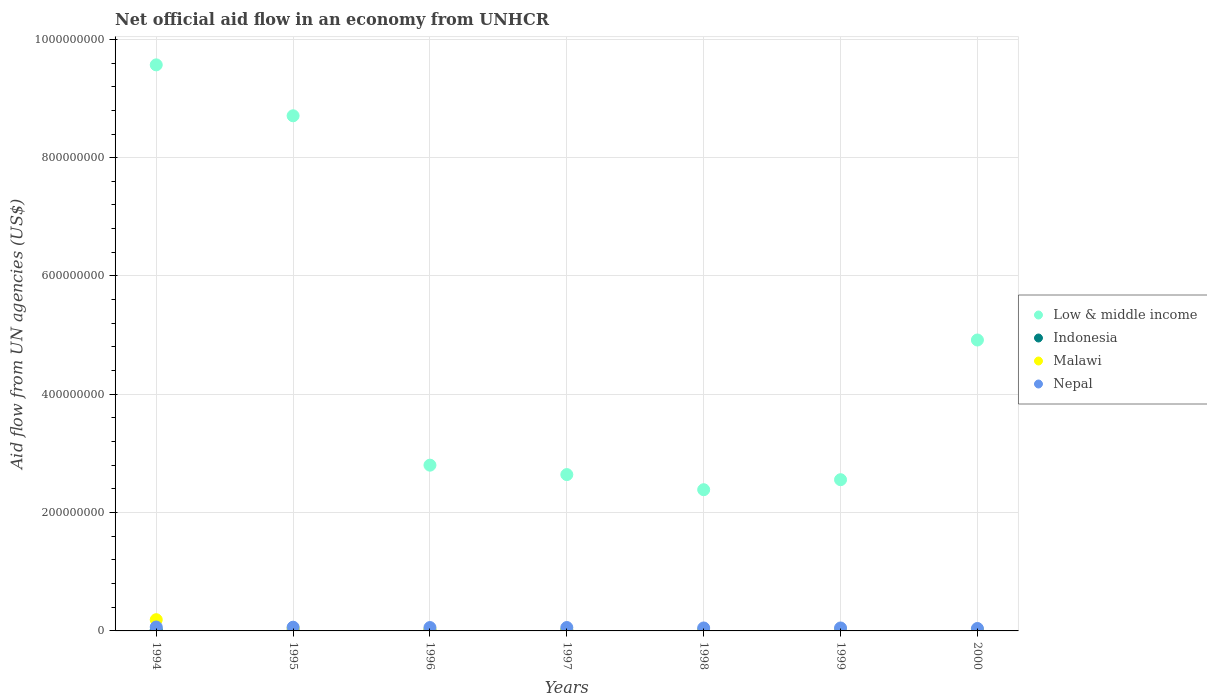Is the number of dotlines equal to the number of legend labels?
Make the answer very short. Yes. What is the net official aid flow in Indonesia in 1994?
Give a very brief answer. 1.96e+06. Across all years, what is the maximum net official aid flow in Malawi?
Offer a terse response. 1.90e+07. Across all years, what is the minimum net official aid flow in Malawi?
Offer a terse response. 7.90e+05. In which year was the net official aid flow in Malawi maximum?
Provide a short and direct response. 1994. What is the total net official aid flow in Nepal in the graph?
Ensure brevity in your answer.  3.84e+07. What is the difference between the net official aid flow in Malawi in 1994 and that in 2000?
Provide a succinct answer. 1.82e+07. What is the difference between the net official aid flow in Malawi in 2000 and the net official aid flow in Low & middle income in 1996?
Provide a short and direct response. -2.79e+08. What is the average net official aid flow in Indonesia per year?
Give a very brief answer. 8.81e+05. In the year 1995, what is the difference between the net official aid flow in Indonesia and net official aid flow in Malawi?
Your answer should be very brief. -3.82e+06. What is the ratio of the net official aid flow in Indonesia in 1999 to that in 2000?
Offer a very short reply. 0.76. Is the difference between the net official aid flow in Indonesia in 1994 and 1998 greater than the difference between the net official aid flow in Malawi in 1994 and 1998?
Provide a succinct answer. No. What is the difference between the highest and the second highest net official aid flow in Nepal?
Ensure brevity in your answer.  3.30e+05. What is the difference between the highest and the lowest net official aid flow in Indonesia?
Offer a very short reply. 1.54e+06. Is it the case that in every year, the sum of the net official aid flow in Indonesia and net official aid flow in Malawi  is greater than the sum of net official aid flow in Nepal and net official aid flow in Low & middle income?
Make the answer very short. No. Is it the case that in every year, the sum of the net official aid flow in Low & middle income and net official aid flow in Nepal  is greater than the net official aid flow in Malawi?
Provide a short and direct response. Yes. Is the net official aid flow in Indonesia strictly greater than the net official aid flow in Nepal over the years?
Make the answer very short. No. How many dotlines are there?
Make the answer very short. 4. How many years are there in the graph?
Your answer should be compact. 7. Are the values on the major ticks of Y-axis written in scientific E-notation?
Your answer should be very brief. No. Where does the legend appear in the graph?
Give a very brief answer. Center right. How are the legend labels stacked?
Your answer should be very brief. Vertical. What is the title of the graph?
Your response must be concise. Net official aid flow in an economy from UNHCR. What is the label or title of the X-axis?
Provide a short and direct response. Years. What is the label or title of the Y-axis?
Ensure brevity in your answer.  Aid flow from UN agencies (US$). What is the Aid flow from UN agencies (US$) of Low & middle income in 1994?
Offer a very short reply. 9.57e+08. What is the Aid flow from UN agencies (US$) of Indonesia in 1994?
Make the answer very short. 1.96e+06. What is the Aid flow from UN agencies (US$) of Malawi in 1994?
Offer a terse response. 1.90e+07. What is the Aid flow from UN agencies (US$) in Nepal in 1994?
Your answer should be compact. 6.61e+06. What is the Aid flow from UN agencies (US$) of Low & middle income in 1995?
Offer a very short reply. 8.71e+08. What is the Aid flow from UN agencies (US$) in Malawi in 1995?
Offer a very short reply. 4.24e+06. What is the Aid flow from UN agencies (US$) of Nepal in 1995?
Provide a succinct answer. 6.28e+06. What is the Aid flow from UN agencies (US$) of Low & middle income in 1996?
Ensure brevity in your answer.  2.80e+08. What is the Aid flow from UN agencies (US$) of Indonesia in 1996?
Offer a very short reply. 5.80e+05. What is the Aid flow from UN agencies (US$) in Malawi in 1996?
Ensure brevity in your answer.  2.13e+06. What is the Aid flow from UN agencies (US$) of Nepal in 1996?
Give a very brief answer. 5.70e+06. What is the Aid flow from UN agencies (US$) of Low & middle income in 1997?
Your response must be concise. 2.64e+08. What is the Aid flow from UN agencies (US$) of Indonesia in 1997?
Provide a succinct answer. 7.30e+05. What is the Aid flow from UN agencies (US$) of Malawi in 1997?
Keep it short and to the point. 1.35e+06. What is the Aid flow from UN agencies (US$) of Nepal in 1997?
Your answer should be very brief. 5.74e+06. What is the Aid flow from UN agencies (US$) in Low & middle income in 1998?
Your response must be concise. 2.39e+08. What is the Aid flow from UN agencies (US$) in Malawi in 1998?
Offer a very short reply. 1.03e+06. What is the Aid flow from UN agencies (US$) of Nepal in 1998?
Your response must be concise. 4.99e+06. What is the Aid flow from UN agencies (US$) of Low & middle income in 1999?
Make the answer very short. 2.56e+08. What is the Aid flow from UN agencies (US$) of Indonesia in 1999?
Ensure brevity in your answer.  8.70e+05. What is the Aid flow from UN agencies (US$) of Malawi in 1999?
Provide a succinct answer. 8.20e+05. What is the Aid flow from UN agencies (US$) in Nepal in 1999?
Keep it short and to the point. 4.98e+06. What is the Aid flow from UN agencies (US$) in Low & middle income in 2000?
Make the answer very short. 4.92e+08. What is the Aid flow from UN agencies (US$) of Indonesia in 2000?
Offer a terse response. 1.14e+06. What is the Aid flow from UN agencies (US$) in Malawi in 2000?
Your answer should be very brief. 7.90e+05. What is the Aid flow from UN agencies (US$) of Nepal in 2000?
Make the answer very short. 4.12e+06. Across all years, what is the maximum Aid flow from UN agencies (US$) of Low & middle income?
Offer a terse response. 9.57e+08. Across all years, what is the maximum Aid flow from UN agencies (US$) of Indonesia?
Your answer should be very brief. 1.96e+06. Across all years, what is the maximum Aid flow from UN agencies (US$) in Malawi?
Offer a terse response. 1.90e+07. Across all years, what is the maximum Aid flow from UN agencies (US$) of Nepal?
Provide a succinct answer. 6.61e+06. Across all years, what is the minimum Aid flow from UN agencies (US$) of Low & middle income?
Your response must be concise. 2.39e+08. Across all years, what is the minimum Aid flow from UN agencies (US$) in Indonesia?
Offer a terse response. 4.20e+05. Across all years, what is the minimum Aid flow from UN agencies (US$) of Malawi?
Ensure brevity in your answer.  7.90e+05. Across all years, what is the minimum Aid flow from UN agencies (US$) in Nepal?
Give a very brief answer. 4.12e+06. What is the total Aid flow from UN agencies (US$) in Low & middle income in the graph?
Offer a terse response. 3.36e+09. What is the total Aid flow from UN agencies (US$) in Indonesia in the graph?
Your answer should be compact. 6.17e+06. What is the total Aid flow from UN agencies (US$) of Malawi in the graph?
Offer a very short reply. 2.93e+07. What is the total Aid flow from UN agencies (US$) of Nepal in the graph?
Your answer should be compact. 3.84e+07. What is the difference between the Aid flow from UN agencies (US$) in Low & middle income in 1994 and that in 1995?
Your response must be concise. 8.61e+07. What is the difference between the Aid flow from UN agencies (US$) in Indonesia in 1994 and that in 1995?
Your response must be concise. 1.54e+06. What is the difference between the Aid flow from UN agencies (US$) in Malawi in 1994 and that in 1995?
Keep it short and to the point. 1.47e+07. What is the difference between the Aid flow from UN agencies (US$) in Low & middle income in 1994 and that in 1996?
Keep it short and to the point. 6.77e+08. What is the difference between the Aid flow from UN agencies (US$) in Indonesia in 1994 and that in 1996?
Ensure brevity in your answer.  1.38e+06. What is the difference between the Aid flow from UN agencies (US$) of Malawi in 1994 and that in 1996?
Offer a terse response. 1.68e+07. What is the difference between the Aid flow from UN agencies (US$) of Nepal in 1994 and that in 1996?
Provide a succinct answer. 9.10e+05. What is the difference between the Aid flow from UN agencies (US$) of Low & middle income in 1994 and that in 1997?
Provide a succinct answer. 6.93e+08. What is the difference between the Aid flow from UN agencies (US$) in Indonesia in 1994 and that in 1997?
Make the answer very short. 1.23e+06. What is the difference between the Aid flow from UN agencies (US$) in Malawi in 1994 and that in 1997?
Your answer should be compact. 1.76e+07. What is the difference between the Aid flow from UN agencies (US$) in Nepal in 1994 and that in 1997?
Keep it short and to the point. 8.70e+05. What is the difference between the Aid flow from UN agencies (US$) in Low & middle income in 1994 and that in 1998?
Keep it short and to the point. 7.18e+08. What is the difference between the Aid flow from UN agencies (US$) in Indonesia in 1994 and that in 1998?
Offer a very short reply. 1.49e+06. What is the difference between the Aid flow from UN agencies (US$) of Malawi in 1994 and that in 1998?
Make the answer very short. 1.80e+07. What is the difference between the Aid flow from UN agencies (US$) in Nepal in 1994 and that in 1998?
Make the answer very short. 1.62e+06. What is the difference between the Aid flow from UN agencies (US$) of Low & middle income in 1994 and that in 1999?
Provide a succinct answer. 7.01e+08. What is the difference between the Aid flow from UN agencies (US$) of Indonesia in 1994 and that in 1999?
Ensure brevity in your answer.  1.09e+06. What is the difference between the Aid flow from UN agencies (US$) in Malawi in 1994 and that in 1999?
Keep it short and to the point. 1.82e+07. What is the difference between the Aid flow from UN agencies (US$) in Nepal in 1994 and that in 1999?
Your answer should be compact. 1.63e+06. What is the difference between the Aid flow from UN agencies (US$) in Low & middle income in 1994 and that in 2000?
Give a very brief answer. 4.65e+08. What is the difference between the Aid flow from UN agencies (US$) in Indonesia in 1994 and that in 2000?
Offer a terse response. 8.20e+05. What is the difference between the Aid flow from UN agencies (US$) of Malawi in 1994 and that in 2000?
Your answer should be compact. 1.82e+07. What is the difference between the Aid flow from UN agencies (US$) of Nepal in 1994 and that in 2000?
Offer a very short reply. 2.49e+06. What is the difference between the Aid flow from UN agencies (US$) of Low & middle income in 1995 and that in 1996?
Give a very brief answer. 5.91e+08. What is the difference between the Aid flow from UN agencies (US$) in Malawi in 1995 and that in 1996?
Offer a terse response. 2.11e+06. What is the difference between the Aid flow from UN agencies (US$) in Nepal in 1995 and that in 1996?
Provide a short and direct response. 5.80e+05. What is the difference between the Aid flow from UN agencies (US$) in Low & middle income in 1995 and that in 1997?
Offer a very short reply. 6.07e+08. What is the difference between the Aid flow from UN agencies (US$) in Indonesia in 1995 and that in 1997?
Keep it short and to the point. -3.10e+05. What is the difference between the Aid flow from UN agencies (US$) in Malawi in 1995 and that in 1997?
Provide a short and direct response. 2.89e+06. What is the difference between the Aid flow from UN agencies (US$) of Nepal in 1995 and that in 1997?
Make the answer very short. 5.40e+05. What is the difference between the Aid flow from UN agencies (US$) in Low & middle income in 1995 and that in 1998?
Give a very brief answer. 6.32e+08. What is the difference between the Aid flow from UN agencies (US$) of Malawi in 1995 and that in 1998?
Your answer should be very brief. 3.21e+06. What is the difference between the Aid flow from UN agencies (US$) in Nepal in 1995 and that in 1998?
Offer a terse response. 1.29e+06. What is the difference between the Aid flow from UN agencies (US$) of Low & middle income in 1995 and that in 1999?
Your answer should be compact. 6.15e+08. What is the difference between the Aid flow from UN agencies (US$) in Indonesia in 1995 and that in 1999?
Ensure brevity in your answer.  -4.50e+05. What is the difference between the Aid flow from UN agencies (US$) of Malawi in 1995 and that in 1999?
Your answer should be compact. 3.42e+06. What is the difference between the Aid flow from UN agencies (US$) in Nepal in 1995 and that in 1999?
Offer a very short reply. 1.30e+06. What is the difference between the Aid flow from UN agencies (US$) of Low & middle income in 1995 and that in 2000?
Make the answer very short. 3.79e+08. What is the difference between the Aid flow from UN agencies (US$) in Indonesia in 1995 and that in 2000?
Provide a succinct answer. -7.20e+05. What is the difference between the Aid flow from UN agencies (US$) of Malawi in 1995 and that in 2000?
Offer a terse response. 3.45e+06. What is the difference between the Aid flow from UN agencies (US$) in Nepal in 1995 and that in 2000?
Provide a succinct answer. 2.16e+06. What is the difference between the Aid flow from UN agencies (US$) in Low & middle income in 1996 and that in 1997?
Make the answer very short. 1.59e+07. What is the difference between the Aid flow from UN agencies (US$) in Indonesia in 1996 and that in 1997?
Make the answer very short. -1.50e+05. What is the difference between the Aid flow from UN agencies (US$) of Malawi in 1996 and that in 1997?
Make the answer very short. 7.80e+05. What is the difference between the Aid flow from UN agencies (US$) in Low & middle income in 1996 and that in 1998?
Provide a short and direct response. 4.15e+07. What is the difference between the Aid flow from UN agencies (US$) of Malawi in 1996 and that in 1998?
Make the answer very short. 1.10e+06. What is the difference between the Aid flow from UN agencies (US$) in Nepal in 1996 and that in 1998?
Your answer should be compact. 7.10e+05. What is the difference between the Aid flow from UN agencies (US$) in Low & middle income in 1996 and that in 1999?
Your response must be concise. 2.46e+07. What is the difference between the Aid flow from UN agencies (US$) of Malawi in 1996 and that in 1999?
Offer a terse response. 1.31e+06. What is the difference between the Aid flow from UN agencies (US$) in Nepal in 1996 and that in 1999?
Your response must be concise. 7.20e+05. What is the difference between the Aid flow from UN agencies (US$) of Low & middle income in 1996 and that in 2000?
Offer a terse response. -2.12e+08. What is the difference between the Aid flow from UN agencies (US$) in Indonesia in 1996 and that in 2000?
Keep it short and to the point. -5.60e+05. What is the difference between the Aid flow from UN agencies (US$) of Malawi in 1996 and that in 2000?
Provide a short and direct response. 1.34e+06. What is the difference between the Aid flow from UN agencies (US$) of Nepal in 1996 and that in 2000?
Keep it short and to the point. 1.58e+06. What is the difference between the Aid flow from UN agencies (US$) in Low & middle income in 1997 and that in 1998?
Offer a terse response. 2.56e+07. What is the difference between the Aid flow from UN agencies (US$) in Nepal in 1997 and that in 1998?
Ensure brevity in your answer.  7.50e+05. What is the difference between the Aid flow from UN agencies (US$) of Low & middle income in 1997 and that in 1999?
Give a very brief answer. 8.64e+06. What is the difference between the Aid flow from UN agencies (US$) in Malawi in 1997 and that in 1999?
Your answer should be very brief. 5.30e+05. What is the difference between the Aid flow from UN agencies (US$) of Nepal in 1997 and that in 1999?
Your answer should be compact. 7.60e+05. What is the difference between the Aid flow from UN agencies (US$) of Low & middle income in 1997 and that in 2000?
Offer a terse response. -2.28e+08. What is the difference between the Aid flow from UN agencies (US$) in Indonesia in 1997 and that in 2000?
Give a very brief answer. -4.10e+05. What is the difference between the Aid flow from UN agencies (US$) in Malawi in 1997 and that in 2000?
Your answer should be very brief. 5.60e+05. What is the difference between the Aid flow from UN agencies (US$) in Nepal in 1997 and that in 2000?
Provide a short and direct response. 1.62e+06. What is the difference between the Aid flow from UN agencies (US$) in Low & middle income in 1998 and that in 1999?
Ensure brevity in your answer.  -1.69e+07. What is the difference between the Aid flow from UN agencies (US$) of Indonesia in 1998 and that in 1999?
Ensure brevity in your answer.  -4.00e+05. What is the difference between the Aid flow from UN agencies (US$) in Low & middle income in 1998 and that in 2000?
Ensure brevity in your answer.  -2.53e+08. What is the difference between the Aid flow from UN agencies (US$) of Indonesia in 1998 and that in 2000?
Your answer should be very brief. -6.70e+05. What is the difference between the Aid flow from UN agencies (US$) of Nepal in 1998 and that in 2000?
Ensure brevity in your answer.  8.70e+05. What is the difference between the Aid flow from UN agencies (US$) of Low & middle income in 1999 and that in 2000?
Your answer should be very brief. -2.36e+08. What is the difference between the Aid flow from UN agencies (US$) in Malawi in 1999 and that in 2000?
Your answer should be compact. 3.00e+04. What is the difference between the Aid flow from UN agencies (US$) in Nepal in 1999 and that in 2000?
Give a very brief answer. 8.60e+05. What is the difference between the Aid flow from UN agencies (US$) of Low & middle income in 1994 and the Aid flow from UN agencies (US$) of Indonesia in 1995?
Give a very brief answer. 9.56e+08. What is the difference between the Aid flow from UN agencies (US$) in Low & middle income in 1994 and the Aid flow from UN agencies (US$) in Malawi in 1995?
Your response must be concise. 9.53e+08. What is the difference between the Aid flow from UN agencies (US$) in Low & middle income in 1994 and the Aid flow from UN agencies (US$) in Nepal in 1995?
Provide a succinct answer. 9.51e+08. What is the difference between the Aid flow from UN agencies (US$) of Indonesia in 1994 and the Aid flow from UN agencies (US$) of Malawi in 1995?
Offer a terse response. -2.28e+06. What is the difference between the Aid flow from UN agencies (US$) of Indonesia in 1994 and the Aid flow from UN agencies (US$) of Nepal in 1995?
Keep it short and to the point. -4.32e+06. What is the difference between the Aid flow from UN agencies (US$) of Malawi in 1994 and the Aid flow from UN agencies (US$) of Nepal in 1995?
Provide a short and direct response. 1.27e+07. What is the difference between the Aid flow from UN agencies (US$) in Low & middle income in 1994 and the Aid flow from UN agencies (US$) in Indonesia in 1996?
Offer a very short reply. 9.56e+08. What is the difference between the Aid flow from UN agencies (US$) of Low & middle income in 1994 and the Aid flow from UN agencies (US$) of Malawi in 1996?
Offer a terse response. 9.55e+08. What is the difference between the Aid flow from UN agencies (US$) in Low & middle income in 1994 and the Aid flow from UN agencies (US$) in Nepal in 1996?
Provide a succinct answer. 9.51e+08. What is the difference between the Aid flow from UN agencies (US$) of Indonesia in 1994 and the Aid flow from UN agencies (US$) of Nepal in 1996?
Your response must be concise. -3.74e+06. What is the difference between the Aid flow from UN agencies (US$) in Malawi in 1994 and the Aid flow from UN agencies (US$) in Nepal in 1996?
Keep it short and to the point. 1.33e+07. What is the difference between the Aid flow from UN agencies (US$) of Low & middle income in 1994 and the Aid flow from UN agencies (US$) of Indonesia in 1997?
Ensure brevity in your answer.  9.56e+08. What is the difference between the Aid flow from UN agencies (US$) of Low & middle income in 1994 and the Aid flow from UN agencies (US$) of Malawi in 1997?
Provide a short and direct response. 9.56e+08. What is the difference between the Aid flow from UN agencies (US$) of Low & middle income in 1994 and the Aid flow from UN agencies (US$) of Nepal in 1997?
Provide a short and direct response. 9.51e+08. What is the difference between the Aid flow from UN agencies (US$) of Indonesia in 1994 and the Aid flow from UN agencies (US$) of Nepal in 1997?
Keep it short and to the point. -3.78e+06. What is the difference between the Aid flow from UN agencies (US$) of Malawi in 1994 and the Aid flow from UN agencies (US$) of Nepal in 1997?
Keep it short and to the point. 1.32e+07. What is the difference between the Aid flow from UN agencies (US$) in Low & middle income in 1994 and the Aid flow from UN agencies (US$) in Indonesia in 1998?
Provide a short and direct response. 9.56e+08. What is the difference between the Aid flow from UN agencies (US$) of Low & middle income in 1994 and the Aid flow from UN agencies (US$) of Malawi in 1998?
Your response must be concise. 9.56e+08. What is the difference between the Aid flow from UN agencies (US$) in Low & middle income in 1994 and the Aid flow from UN agencies (US$) in Nepal in 1998?
Ensure brevity in your answer.  9.52e+08. What is the difference between the Aid flow from UN agencies (US$) in Indonesia in 1994 and the Aid flow from UN agencies (US$) in Malawi in 1998?
Your answer should be compact. 9.30e+05. What is the difference between the Aid flow from UN agencies (US$) in Indonesia in 1994 and the Aid flow from UN agencies (US$) in Nepal in 1998?
Make the answer very short. -3.03e+06. What is the difference between the Aid flow from UN agencies (US$) in Malawi in 1994 and the Aid flow from UN agencies (US$) in Nepal in 1998?
Ensure brevity in your answer.  1.40e+07. What is the difference between the Aid flow from UN agencies (US$) in Low & middle income in 1994 and the Aid flow from UN agencies (US$) in Indonesia in 1999?
Give a very brief answer. 9.56e+08. What is the difference between the Aid flow from UN agencies (US$) in Low & middle income in 1994 and the Aid flow from UN agencies (US$) in Malawi in 1999?
Offer a terse response. 9.56e+08. What is the difference between the Aid flow from UN agencies (US$) of Low & middle income in 1994 and the Aid flow from UN agencies (US$) of Nepal in 1999?
Make the answer very short. 9.52e+08. What is the difference between the Aid flow from UN agencies (US$) of Indonesia in 1994 and the Aid flow from UN agencies (US$) of Malawi in 1999?
Your answer should be very brief. 1.14e+06. What is the difference between the Aid flow from UN agencies (US$) in Indonesia in 1994 and the Aid flow from UN agencies (US$) in Nepal in 1999?
Your response must be concise. -3.02e+06. What is the difference between the Aid flow from UN agencies (US$) of Malawi in 1994 and the Aid flow from UN agencies (US$) of Nepal in 1999?
Offer a terse response. 1.40e+07. What is the difference between the Aid flow from UN agencies (US$) in Low & middle income in 1994 and the Aid flow from UN agencies (US$) in Indonesia in 2000?
Keep it short and to the point. 9.56e+08. What is the difference between the Aid flow from UN agencies (US$) of Low & middle income in 1994 and the Aid flow from UN agencies (US$) of Malawi in 2000?
Offer a very short reply. 9.56e+08. What is the difference between the Aid flow from UN agencies (US$) in Low & middle income in 1994 and the Aid flow from UN agencies (US$) in Nepal in 2000?
Offer a very short reply. 9.53e+08. What is the difference between the Aid flow from UN agencies (US$) in Indonesia in 1994 and the Aid flow from UN agencies (US$) in Malawi in 2000?
Ensure brevity in your answer.  1.17e+06. What is the difference between the Aid flow from UN agencies (US$) in Indonesia in 1994 and the Aid flow from UN agencies (US$) in Nepal in 2000?
Offer a very short reply. -2.16e+06. What is the difference between the Aid flow from UN agencies (US$) of Malawi in 1994 and the Aid flow from UN agencies (US$) of Nepal in 2000?
Your answer should be very brief. 1.49e+07. What is the difference between the Aid flow from UN agencies (US$) of Low & middle income in 1995 and the Aid flow from UN agencies (US$) of Indonesia in 1996?
Your answer should be compact. 8.70e+08. What is the difference between the Aid flow from UN agencies (US$) of Low & middle income in 1995 and the Aid flow from UN agencies (US$) of Malawi in 1996?
Offer a terse response. 8.69e+08. What is the difference between the Aid flow from UN agencies (US$) of Low & middle income in 1995 and the Aid flow from UN agencies (US$) of Nepal in 1996?
Give a very brief answer. 8.65e+08. What is the difference between the Aid flow from UN agencies (US$) of Indonesia in 1995 and the Aid flow from UN agencies (US$) of Malawi in 1996?
Make the answer very short. -1.71e+06. What is the difference between the Aid flow from UN agencies (US$) in Indonesia in 1995 and the Aid flow from UN agencies (US$) in Nepal in 1996?
Your answer should be very brief. -5.28e+06. What is the difference between the Aid flow from UN agencies (US$) of Malawi in 1995 and the Aid flow from UN agencies (US$) of Nepal in 1996?
Provide a succinct answer. -1.46e+06. What is the difference between the Aid flow from UN agencies (US$) of Low & middle income in 1995 and the Aid flow from UN agencies (US$) of Indonesia in 1997?
Your response must be concise. 8.70e+08. What is the difference between the Aid flow from UN agencies (US$) in Low & middle income in 1995 and the Aid flow from UN agencies (US$) in Malawi in 1997?
Provide a short and direct response. 8.69e+08. What is the difference between the Aid flow from UN agencies (US$) of Low & middle income in 1995 and the Aid flow from UN agencies (US$) of Nepal in 1997?
Provide a succinct answer. 8.65e+08. What is the difference between the Aid flow from UN agencies (US$) of Indonesia in 1995 and the Aid flow from UN agencies (US$) of Malawi in 1997?
Your answer should be very brief. -9.30e+05. What is the difference between the Aid flow from UN agencies (US$) of Indonesia in 1995 and the Aid flow from UN agencies (US$) of Nepal in 1997?
Make the answer very short. -5.32e+06. What is the difference between the Aid flow from UN agencies (US$) in Malawi in 1995 and the Aid flow from UN agencies (US$) in Nepal in 1997?
Offer a terse response. -1.50e+06. What is the difference between the Aid flow from UN agencies (US$) of Low & middle income in 1995 and the Aid flow from UN agencies (US$) of Indonesia in 1998?
Your answer should be compact. 8.70e+08. What is the difference between the Aid flow from UN agencies (US$) in Low & middle income in 1995 and the Aid flow from UN agencies (US$) in Malawi in 1998?
Your answer should be very brief. 8.70e+08. What is the difference between the Aid flow from UN agencies (US$) of Low & middle income in 1995 and the Aid flow from UN agencies (US$) of Nepal in 1998?
Your answer should be compact. 8.66e+08. What is the difference between the Aid flow from UN agencies (US$) in Indonesia in 1995 and the Aid flow from UN agencies (US$) in Malawi in 1998?
Your answer should be very brief. -6.10e+05. What is the difference between the Aid flow from UN agencies (US$) in Indonesia in 1995 and the Aid flow from UN agencies (US$) in Nepal in 1998?
Your answer should be compact. -4.57e+06. What is the difference between the Aid flow from UN agencies (US$) of Malawi in 1995 and the Aid flow from UN agencies (US$) of Nepal in 1998?
Provide a succinct answer. -7.50e+05. What is the difference between the Aid flow from UN agencies (US$) in Low & middle income in 1995 and the Aid flow from UN agencies (US$) in Indonesia in 1999?
Ensure brevity in your answer.  8.70e+08. What is the difference between the Aid flow from UN agencies (US$) of Low & middle income in 1995 and the Aid flow from UN agencies (US$) of Malawi in 1999?
Your answer should be very brief. 8.70e+08. What is the difference between the Aid flow from UN agencies (US$) of Low & middle income in 1995 and the Aid flow from UN agencies (US$) of Nepal in 1999?
Provide a succinct answer. 8.66e+08. What is the difference between the Aid flow from UN agencies (US$) in Indonesia in 1995 and the Aid flow from UN agencies (US$) in Malawi in 1999?
Your answer should be very brief. -4.00e+05. What is the difference between the Aid flow from UN agencies (US$) of Indonesia in 1995 and the Aid flow from UN agencies (US$) of Nepal in 1999?
Offer a very short reply. -4.56e+06. What is the difference between the Aid flow from UN agencies (US$) in Malawi in 1995 and the Aid flow from UN agencies (US$) in Nepal in 1999?
Your answer should be compact. -7.40e+05. What is the difference between the Aid flow from UN agencies (US$) in Low & middle income in 1995 and the Aid flow from UN agencies (US$) in Indonesia in 2000?
Provide a succinct answer. 8.70e+08. What is the difference between the Aid flow from UN agencies (US$) of Low & middle income in 1995 and the Aid flow from UN agencies (US$) of Malawi in 2000?
Offer a terse response. 8.70e+08. What is the difference between the Aid flow from UN agencies (US$) of Low & middle income in 1995 and the Aid flow from UN agencies (US$) of Nepal in 2000?
Offer a very short reply. 8.67e+08. What is the difference between the Aid flow from UN agencies (US$) of Indonesia in 1995 and the Aid flow from UN agencies (US$) of Malawi in 2000?
Provide a succinct answer. -3.70e+05. What is the difference between the Aid flow from UN agencies (US$) of Indonesia in 1995 and the Aid flow from UN agencies (US$) of Nepal in 2000?
Keep it short and to the point. -3.70e+06. What is the difference between the Aid flow from UN agencies (US$) in Malawi in 1995 and the Aid flow from UN agencies (US$) in Nepal in 2000?
Provide a short and direct response. 1.20e+05. What is the difference between the Aid flow from UN agencies (US$) in Low & middle income in 1996 and the Aid flow from UN agencies (US$) in Indonesia in 1997?
Your response must be concise. 2.79e+08. What is the difference between the Aid flow from UN agencies (US$) of Low & middle income in 1996 and the Aid flow from UN agencies (US$) of Malawi in 1997?
Offer a very short reply. 2.79e+08. What is the difference between the Aid flow from UN agencies (US$) of Low & middle income in 1996 and the Aid flow from UN agencies (US$) of Nepal in 1997?
Ensure brevity in your answer.  2.74e+08. What is the difference between the Aid flow from UN agencies (US$) in Indonesia in 1996 and the Aid flow from UN agencies (US$) in Malawi in 1997?
Make the answer very short. -7.70e+05. What is the difference between the Aid flow from UN agencies (US$) in Indonesia in 1996 and the Aid flow from UN agencies (US$) in Nepal in 1997?
Your response must be concise. -5.16e+06. What is the difference between the Aid flow from UN agencies (US$) of Malawi in 1996 and the Aid flow from UN agencies (US$) of Nepal in 1997?
Your answer should be compact. -3.61e+06. What is the difference between the Aid flow from UN agencies (US$) in Low & middle income in 1996 and the Aid flow from UN agencies (US$) in Indonesia in 1998?
Give a very brief answer. 2.80e+08. What is the difference between the Aid flow from UN agencies (US$) in Low & middle income in 1996 and the Aid flow from UN agencies (US$) in Malawi in 1998?
Your response must be concise. 2.79e+08. What is the difference between the Aid flow from UN agencies (US$) in Low & middle income in 1996 and the Aid flow from UN agencies (US$) in Nepal in 1998?
Your response must be concise. 2.75e+08. What is the difference between the Aid flow from UN agencies (US$) in Indonesia in 1996 and the Aid flow from UN agencies (US$) in Malawi in 1998?
Ensure brevity in your answer.  -4.50e+05. What is the difference between the Aid flow from UN agencies (US$) of Indonesia in 1996 and the Aid flow from UN agencies (US$) of Nepal in 1998?
Offer a very short reply. -4.41e+06. What is the difference between the Aid flow from UN agencies (US$) in Malawi in 1996 and the Aid flow from UN agencies (US$) in Nepal in 1998?
Your answer should be very brief. -2.86e+06. What is the difference between the Aid flow from UN agencies (US$) of Low & middle income in 1996 and the Aid flow from UN agencies (US$) of Indonesia in 1999?
Your answer should be very brief. 2.79e+08. What is the difference between the Aid flow from UN agencies (US$) in Low & middle income in 1996 and the Aid flow from UN agencies (US$) in Malawi in 1999?
Ensure brevity in your answer.  2.79e+08. What is the difference between the Aid flow from UN agencies (US$) in Low & middle income in 1996 and the Aid flow from UN agencies (US$) in Nepal in 1999?
Your answer should be compact. 2.75e+08. What is the difference between the Aid flow from UN agencies (US$) of Indonesia in 1996 and the Aid flow from UN agencies (US$) of Malawi in 1999?
Your answer should be compact. -2.40e+05. What is the difference between the Aid flow from UN agencies (US$) in Indonesia in 1996 and the Aid flow from UN agencies (US$) in Nepal in 1999?
Provide a short and direct response. -4.40e+06. What is the difference between the Aid flow from UN agencies (US$) in Malawi in 1996 and the Aid flow from UN agencies (US$) in Nepal in 1999?
Offer a terse response. -2.85e+06. What is the difference between the Aid flow from UN agencies (US$) in Low & middle income in 1996 and the Aid flow from UN agencies (US$) in Indonesia in 2000?
Make the answer very short. 2.79e+08. What is the difference between the Aid flow from UN agencies (US$) of Low & middle income in 1996 and the Aid flow from UN agencies (US$) of Malawi in 2000?
Make the answer very short. 2.79e+08. What is the difference between the Aid flow from UN agencies (US$) of Low & middle income in 1996 and the Aid flow from UN agencies (US$) of Nepal in 2000?
Give a very brief answer. 2.76e+08. What is the difference between the Aid flow from UN agencies (US$) in Indonesia in 1996 and the Aid flow from UN agencies (US$) in Malawi in 2000?
Your answer should be very brief. -2.10e+05. What is the difference between the Aid flow from UN agencies (US$) of Indonesia in 1996 and the Aid flow from UN agencies (US$) of Nepal in 2000?
Ensure brevity in your answer.  -3.54e+06. What is the difference between the Aid flow from UN agencies (US$) of Malawi in 1996 and the Aid flow from UN agencies (US$) of Nepal in 2000?
Ensure brevity in your answer.  -1.99e+06. What is the difference between the Aid flow from UN agencies (US$) in Low & middle income in 1997 and the Aid flow from UN agencies (US$) in Indonesia in 1998?
Offer a very short reply. 2.64e+08. What is the difference between the Aid flow from UN agencies (US$) of Low & middle income in 1997 and the Aid flow from UN agencies (US$) of Malawi in 1998?
Provide a short and direct response. 2.63e+08. What is the difference between the Aid flow from UN agencies (US$) in Low & middle income in 1997 and the Aid flow from UN agencies (US$) in Nepal in 1998?
Provide a succinct answer. 2.59e+08. What is the difference between the Aid flow from UN agencies (US$) in Indonesia in 1997 and the Aid flow from UN agencies (US$) in Nepal in 1998?
Your answer should be compact. -4.26e+06. What is the difference between the Aid flow from UN agencies (US$) in Malawi in 1997 and the Aid flow from UN agencies (US$) in Nepal in 1998?
Provide a succinct answer. -3.64e+06. What is the difference between the Aid flow from UN agencies (US$) of Low & middle income in 1997 and the Aid flow from UN agencies (US$) of Indonesia in 1999?
Provide a short and direct response. 2.63e+08. What is the difference between the Aid flow from UN agencies (US$) in Low & middle income in 1997 and the Aid flow from UN agencies (US$) in Malawi in 1999?
Offer a terse response. 2.63e+08. What is the difference between the Aid flow from UN agencies (US$) of Low & middle income in 1997 and the Aid flow from UN agencies (US$) of Nepal in 1999?
Your answer should be very brief. 2.59e+08. What is the difference between the Aid flow from UN agencies (US$) in Indonesia in 1997 and the Aid flow from UN agencies (US$) in Nepal in 1999?
Provide a short and direct response. -4.25e+06. What is the difference between the Aid flow from UN agencies (US$) of Malawi in 1997 and the Aid flow from UN agencies (US$) of Nepal in 1999?
Your answer should be compact. -3.63e+06. What is the difference between the Aid flow from UN agencies (US$) of Low & middle income in 1997 and the Aid flow from UN agencies (US$) of Indonesia in 2000?
Keep it short and to the point. 2.63e+08. What is the difference between the Aid flow from UN agencies (US$) in Low & middle income in 1997 and the Aid flow from UN agencies (US$) in Malawi in 2000?
Make the answer very short. 2.63e+08. What is the difference between the Aid flow from UN agencies (US$) in Low & middle income in 1997 and the Aid flow from UN agencies (US$) in Nepal in 2000?
Provide a short and direct response. 2.60e+08. What is the difference between the Aid flow from UN agencies (US$) of Indonesia in 1997 and the Aid flow from UN agencies (US$) of Nepal in 2000?
Provide a succinct answer. -3.39e+06. What is the difference between the Aid flow from UN agencies (US$) of Malawi in 1997 and the Aid flow from UN agencies (US$) of Nepal in 2000?
Provide a succinct answer. -2.77e+06. What is the difference between the Aid flow from UN agencies (US$) of Low & middle income in 1998 and the Aid flow from UN agencies (US$) of Indonesia in 1999?
Provide a succinct answer. 2.38e+08. What is the difference between the Aid flow from UN agencies (US$) of Low & middle income in 1998 and the Aid flow from UN agencies (US$) of Malawi in 1999?
Your response must be concise. 2.38e+08. What is the difference between the Aid flow from UN agencies (US$) of Low & middle income in 1998 and the Aid flow from UN agencies (US$) of Nepal in 1999?
Give a very brief answer. 2.34e+08. What is the difference between the Aid flow from UN agencies (US$) of Indonesia in 1998 and the Aid flow from UN agencies (US$) of Malawi in 1999?
Make the answer very short. -3.50e+05. What is the difference between the Aid flow from UN agencies (US$) of Indonesia in 1998 and the Aid flow from UN agencies (US$) of Nepal in 1999?
Your answer should be compact. -4.51e+06. What is the difference between the Aid flow from UN agencies (US$) in Malawi in 1998 and the Aid flow from UN agencies (US$) in Nepal in 1999?
Provide a short and direct response. -3.95e+06. What is the difference between the Aid flow from UN agencies (US$) in Low & middle income in 1998 and the Aid flow from UN agencies (US$) in Indonesia in 2000?
Offer a very short reply. 2.38e+08. What is the difference between the Aid flow from UN agencies (US$) of Low & middle income in 1998 and the Aid flow from UN agencies (US$) of Malawi in 2000?
Provide a short and direct response. 2.38e+08. What is the difference between the Aid flow from UN agencies (US$) in Low & middle income in 1998 and the Aid flow from UN agencies (US$) in Nepal in 2000?
Your answer should be compact. 2.35e+08. What is the difference between the Aid flow from UN agencies (US$) in Indonesia in 1998 and the Aid flow from UN agencies (US$) in Malawi in 2000?
Ensure brevity in your answer.  -3.20e+05. What is the difference between the Aid flow from UN agencies (US$) in Indonesia in 1998 and the Aid flow from UN agencies (US$) in Nepal in 2000?
Provide a succinct answer. -3.65e+06. What is the difference between the Aid flow from UN agencies (US$) of Malawi in 1998 and the Aid flow from UN agencies (US$) of Nepal in 2000?
Provide a succinct answer. -3.09e+06. What is the difference between the Aid flow from UN agencies (US$) in Low & middle income in 1999 and the Aid flow from UN agencies (US$) in Indonesia in 2000?
Offer a very short reply. 2.54e+08. What is the difference between the Aid flow from UN agencies (US$) of Low & middle income in 1999 and the Aid flow from UN agencies (US$) of Malawi in 2000?
Your answer should be very brief. 2.55e+08. What is the difference between the Aid flow from UN agencies (US$) of Low & middle income in 1999 and the Aid flow from UN agencies (US$) of Nepal in 2000?
Your response must be concise. 2.52e+08. What is the difference between the Aid flow from UN agencies (US$) of Indonesia in 1999 and the Aid flow from UN agencies (US$) of Malawi in 2000?
Provide a short and direct response. 8.00e+04. What is the difference between the Aid flow from UN agencies (US$) in Indonesia in 1999 and the Aid flow from UN agencies (US$) in Nepal in 2000?
Your answer should be compact. -3.25e+06. What is the difference between the Aid flow from UN agencies (US$) of Malawi in 1999 and the Aid flow from UN agencies (US$) of Nepal in 2000?
Provide a short and direct response. -3.30e+06. What is the average Aid flow from UN agencies (US$) in Low & middle income per year?
Offer a terse response. 4.80e+08. What is the average Aid flow from UN agencies (US$) in Indonesia per year?
Make the answer very short. 8.81e+05. What is the average Aid flow from UN agencies (US$) of Malawi per year?
Offer a terse response. 4.19e+06. What is the average Aid flow from UN agencies (US$) of Nepal per year?
Offer a very short reply. 5.49e+06. In the year 1994, what is the difference between the Aid flow from UN agencies (US$) of Low & middle income and Aid flow from UN agencies (US$) of Indonesia?
Provide a succinct answer. 9.55e+08. In the year 1994, what is the difference between the Aid flow from UN agencies (US$) of Low & middle income and Aid flow from UN agencies (US$) of Malawi?
Your answer should be compact. 9.38e+08. In the year 1994, what is the difference between the Aid flow from UN agencies (US$) in Low & middle income and Aid flow from UN agencies (US$) in Nepal?
Give a very brief answer. 9.50e+08. In the year 1994, what is the difference between the Aid flow from UN agencies (US$) of Indonesia and Aid flow from UN agencies (US$) of Malawi?
Your answer should be compact. -1.70e+07. In the year 1994, what is the difference between the Aid flow from UN agencies (US$) of Indonesia and Aid flow from UN agencies (US$) of Nepal?
Your answer should be very brief. -4.65e+06. In the year 1994, what is the difference between the Aid flow from UN agencies (US$) of Malawi and Aid flow from UN agencies (US$) of Nepal?
Provide a succinct answer. 1.24e+07. In the year 1995, what is the difference between the Aid flow from UN agencies (US$) in Low & middle income and Aid flow from UN agencies (US$) in Indonesia?
Ensure brevity in your answer.  8.70e+08. In the year 1995, what is the difference between the Aid flow from UN agencies (US$) of Low & middle income and Aid flow from UN agencies (US$) of Malawi?
Provide a short and direct response. 8.67e+08. In the year 1995, what is the difference between the Aid flow from UN agencies (US$) in Low & middle income and Aid flow from UN agencies (US$) in Nepal?
Make the answer very short. 8.65e+08. In the year 1995, what is the difference between the Aid flow from UN agencies (US$) of Indonesia and Aid flow from UN agencies (US$) of Malawi?
Keep it short and to the point. -3.82e+06. In the year 1995, what is the difference between the Aid flow from UN agencies (US$) of Indonesia and Aid flow from UN agencies (US$) of Nepal?
Offer a very short reply. -5.86e+06. In the year 1995, what is the difference between the Aid flow from UN agencies (US$) of Malawi and Aid flow from UN agencies (US$) of Nepal?
Keep it short and to the point. -2.04e+06. In the year 1996, what is the difference between the Aid flow from UN agencies (US$) of Low & middle income and Aid flow from UN agencies (US$) of Indonesia?
Offer a very short reply. 2.80e+08. In the year 1996, what is the difference between the Aid flow from UN agencies (US$) of Low & middle income and Aid flow from UN agencies (US$) of Malawi?
Make the answer very short. 2.78e+08. In the year 1996, what is the difference between the Aid flow from UN agencies (US$) of Low & middle income and Aid flow from UN agencies (US$) of Nepal?
Make the answer very short. 2.75e+08. In the year 1996, what is the difference between the Aid flow from UN agencies (US$) in Indonesia and Aid flow from UN agencies (US$) in Malawi?
Give a very brief answer. -1.55e+06. In the year 1996, what is the difference between the Aid flow from UN agencies (US$) of Indonesia and Aid flow from UN agencies (US$) of Nepal?
Your response must be concise. -5.12e+06. In the year 1996, what is the difference between the Aid flow from UN agencies (US$) in Malawi and Aid flow from UN agencies (US$) in Nepal?
Give a very brief answer. -3.57e+06. In the year 1997, what is the difference between the Aid flow from UN agencies (US$) in Low & middle income and Aid flow from UN agencies (US$) in Indonesia?
Offer a terse response. 2.64e+08. In the year 1997, what is the difference between the Aid flow from UN agencies (US$) of Low & middle income and Aid flow from UN agencies (US$) of Malawi?
Ensure brevity in your answer.  2.63e+08. In the year 1997, what is the difference between the Aid flow from UN agencies (US$) of Low & middle income and Aid flow from UN agencies (US$) of Nepal?
Give a very brief answer. 2.59e+08. In the year 1997, what is the difference between the Aid flow from UN agencies (US$) in Indonesia and Aid flow from UN agencies (US$) in Malawi?
Give a very brief answer. -6.20e+05. In the year 1997, what is the difference between the Aid flow from UN agencies (US$) in Indonesia and Aid flow from UN agencies (US$) in Nepal?
Offer a terse response. -5.01e+06. In the year 1997, what is the difference between the Aid flow from UN agencies (US$) of Malawi and Aid flow from UN agencies (US$) of Nepal?
Give a very brief answer. -4.39e+06. In the year 1998, what is the difference between the Aid flow from UN agencies (US$) of Low & middle income and Aid flow from UN agencies (US$) of Indonesia?
Provide a short and direct response. 2.38e+08. In the year 1998, what is the difference between the Aid flow from UN agencies (US$) in Low & middle income and Aid flow from UN agencies (US$) in Malawi?
Your answer should be very brief. 2.38e+08. In the year 1998, what is the difference between the Aid flow from UN agencies (US$) in Low & middle income and Aid flow from UN agencies (US$) in Nepal?
Make the answer very short. 2.34e+08. In the year 1998, what is the difference between the Aid flow from UN agencies (US$) in Indonesia and Aid flow from UN agencies (US$) in Malawi?
Ensure brevity in your answer.  -5.60e+05. In the year 1998, what is the difference between the Aid flow from UN agencies (US$) in Indonesia and Aid flow from UN agencies (US$) in Nepal?
Your answer should be compact. -4.52e+06. In the year 1998, what is the difference between the Aid flow from UN agencies (US$) of Malawi and Aid flow from UN agencies (US$) of Nepal?
Your answer should be very brief. -3.96e+06. In the year 1999, what is the difference between the Aid flow from UN agencies (US$) of Low & middle income and Aid flow from UN agencies (US$) of Indonesia?
Offer a terse response. 2.55e+08. In the year 1999, what is the difference between the Aid flow from UN agencies (US$) of Low & middle income and Aid flow from UN agencies (US$) of Malawi?
Your answer should be very brief. 2.55e+08. In the year 1999, what is the difference between the Aid flow from UN agencies (US$) of Low & middle income and Aid flow from UN agencies (US$) of Nepal?
Keep it short and to the point. 2.51e+08. In the year 1999, what is the difference between the Aid flow from UN agencies (US$) of Indonesia and Aid flow from UN agencies (US$) of Malawi?
Your answer should be compact. 5.00e+04. In the year 1999, what is the difference between the Aid flow from UN agencies (US$) of Indonesia and Aid flow from UN agencies (US$) of Nepal?
Your answer should be very brief. -4.11e+06. In the year 1999, what is the difference between the Aid flow from UN agencies (US$) in Malawi and Aid flow from UN agencies (US$) in Nepal?
Keep it short and to the point. -4.16e+06. In the year 2000, what is the difference between the Aid flow from UN agencies (US$) in Low & middle income and Aid flow from UN agencies (US$) in Indonesia?
Ensure brevity in your answer.  4.91e+08. In the year 2000, what is the difference between the Aid flow from UN agencies (US$) in Low & middle income and Aid flow from UN agencies (US$) in Malawi?
Keep it short and to the point. 4.91e+08. In the year 2000, what is the difference between the Aid flow from UN agencies (US$) of Low & middle income and Aid flow from UN agencies (US$) of Nepal?
Your answer should be compact. 4.88e+08. In the year 2000, what is the difference between the Aid flow from UN agencies (US$) of Indonesia and Aid flow from UN agencies (US$) of Malawi?
Provide a succinct answer. 3.50e+05. In the year 2000, what is the difference between the Aid flow from UN agencies (US$) in Indonesia and Aid flow from UN agencies (US$) in Nepal?
Provide a short and direct response. -2.98e+06. In the year 2000, what is the difference between the Aid flow from UN agencies (US$) of Malawi and Aid flow from UN agencies (US$) of Nepal?
Your response must be concise. -3.33e+06. What is the ratio of the Aid flow from UN agencies (US$) in Low & middle income in 1994 to that in 1995?
Your answer should be compact. 1.1. What is the ratio of the Aid flow from UN agencies (US$) of Indonesia in 1994 to that in 1995?
Offer a terse response. 4.67. What is the ratio of the Aid flow from UN agencies (US$) of Malawi in 1994 to that in 1995?
Your answer should be compact. 4.48. What is the ratio of the Aid flow from UN agencies (US$) in Nepal in 1994 to that in 1995?
Provide a succinct answer. 1.05. What is the ratio of the Aid flow from UN agencies (US$) in Low & middle income in 1994 to that in 1996?
Keep it short and to the point. 3.41. What is the ratio of the Aid flow from UN agencies (US$) in Indonesia in 1994 to that in 1996?
Provide a short and direct response. 3.38. What is the ratio of the Aid flow from UN agencies (US$) in Malawi in 1994 to that in 1996?
Your answer should be compact. 8.91. What is the ratio of the Aid flow from UN agencies (US$) in Nepal in 1994 to that in 1996?
Your answer should be very brief. 1.16. What is the ratio of the Aid flow from UN agencies (US$) of Low & middle income in 1994 to that in 1997?
Keep it short and to the point. 3.62. What is the ratio of the Aid flow from UN agencies (US$) of Indonesia in 1994 to that in 1997?
Make the answer very short. 2.68. What is the ratio of the Aid flow from UN agencies (US$) of Malawi in 1994 to that in 1997?
Ensure brevity in your answer.  14.06. What is the ratio of the Aid flow from UN agencies (US$) in Nepal in 1994 to that in 1997?
Your answer should be compact. 1.15. What is the ratio of the Aid flow from UN agencies (US$) of Low & middle income in 1994 to that in 1998?
Make the answer very short. 4.01. What is the ratio of the Aid flow from UN agencies (US$) of Indonesia in 1994 to that in 1998?
Provide a short and direct response. 4.17. What is the ratio of the Aid flow from UN agencies (US$) of Malawi in 1994 to that in 1998?
Make the answer very short. 18.43. What is the ratio of the Aid flow from UN agencies (US$) in Nepal in 1994 to that in 1998?
Give a very brief answer. 1.32. What is the ratio of the Aid flow from UN agencies (US$) of Low & middle income in 1994 to that in 1999?
Ensure brevity in your answer.  3.74. What is the ratio of the Aid flow from UN agencies (US$) of Indonesia in 1994 to that in 1999?
Offer a terse response. 2.25. What is the ratio of the Aid flow from UN agencies (US$) in Malawi in 1994 to that in 1999?
Give a very brief answer. 23.15. What is the ratio of the Aid flow from UN agencies (US$) of Nepal in 1994 to that in 1999?
Your response must be concise. 1.33. What is the ratio of the Aid flow from UN agencies (US$) in Low & middle income in 1994 to that in 2000?
Your answer should be compact. 1.95. What is the ratio of the Aid flow from UN agencies (US$) in Indonesia in 1994 to that in 2000?
Your answer should be very brief. 1.72. What is the ratio of the Aid flow from UN agencies (US$) of Malawi in 1994 to that in 2000?
Your answer should be compact. 24.03. What is the ratio of the Aid flow from UN agencies (US$) of Nepal in 1994 to that in 2000?
Ensure brevity in your answer.  1.6. What is the ratio of the Aid flow from UN agencies (US$) of Low & middle income in 1995 to that in 1996?
Offer a very short reply. 3.11. What is the ratio of the Aid flow from UN agencies (US$) in Indonesia in 1995 to that in 1996?
Offer a terse response. 0.72. What is the ratio of the Aid flow from UN agencies (US$) in Malawi in 1995 to that in 1996?
Your response must be concise. 1.99. What is the ratio of the Aid flow from UN agencies (US$) of Nepal in 1995 to that in 1996?
Your answer should be very brief. 1.1. What is the ratio of the Aid flow from UN agencies (US$) of Low & middle income in 1995 to that in 1997?
Give a very brief answer. 3.3. What is the ratio of the Aid flow from UN agencies (US$) in Indonesia in 1995 to that in 1997?
Give a very brief answer. 0.58. What is the ratio of the Aid flow from UN agencies (US$) in Malawi in 1995 to that in 1997?
Offer a terse response. 3.14. What is the ratio of the Aid flow from UN agencies (US$) of Nepal in 1995 to that in 1997?
Provide a short and direct response. 1.09. What is the ratio of the Aid flow from UN agencies (US$) in Low & middle income in 1995 to that in 1998?
Offer a terse response. 3.65. What is the ratio of the Aid flow from UN agencies (US$) of Indonesia in 1995 to that in 1998?
Ensure brevity in your answer.  0.89. What is the ratio of the Aid flow from UN agencies (US$) in Malawi in 1995 to that in 1998?
Keep it short and to the point. 4.12. What is the ratio of the Aid flow from UN agencies (US$) in Nepal in 1995 to that in 1998?
Keep it short and to the point. 1.26. What is the ratio of the Aid flow from UN agencies (US$) in Low & middle income in 1995 to that in 1999?
Your response must be concise. 3.41. What is the ratio of the Aid flow from UN agencies (US$) of Indonesia in 1995 to that in 1999?
Your answer should be compact. 0.48. What is the ratio of the Aid flow from UN agencies (US$) in Malawi in 1995 to that in 1999?
Make the answer very short. 5.17. What is the ratio of the Aid flow from UN agencies (US$) of Nepal in 1995 to that in 1999?
Give a very brief answer. 1.26. What is the ratio of the Aid flow from UN agencies (US$) in Low & middle income in 1995 to that in 2000?
Your answer should be very brief. 1.77. What is the ratio of the Aid flow from UN agencies (US$) of Indonesia in 1995 to that in 2000?
Your response must be concise. 0.37. What is the ratio of the Aid flow from UN agencies (US$) in Malawi in 1995 to that in 2000?
Keep it short and to the point. 5.37. What is the ratio of the Aid flow from UN agencies (US$) of Nepal in 1995 to that in 2000?
Your answer should be very brief. 1.52. What is the ratio of the Aid flow from UN agencies (US$) of Low & middle income in 1996 to that in 1997?
Offer a terse response. 1.06. What is the ratio of the Aid flow from UN agencies (US$) of Indonesia in 1996 to that in 1997?
Give a very brief answer. 0.79. What is the ratio of the Aid flow from UN agencies (US$) of Malawi in 1996 to that in 1997?
Your answer should be very brief. 1.58. What is the ratio of the Aid flow from UN agencies (US$) in Nepal in 1996 to that in 1997?
Offer a terse response. 0.99. What is the ratio of the Aid flow from UN agencies (US$) in Low & middle income in 1996 to that in 1998?
Offer a terse response. 1.17. What is the ratio of the Aid flow from UN agencies (US$) of Indonesia in 1996 to that in 1998?
Your response must be concise. 1.23. What is the ratio of the Aid flow from UN agencies (US$) in Malawi in 1996 to that in 1998?
Keep it short and to the point. 2.07. What is the ratio of the Aid flow from UN agencies (US$) in Nepal in 1996 to that in 1998?
Give a very brief answer. 1.14. What is the ratio of the Aid flow from UN agencies (US$) of Low & middle income in 1996 to that in 1999?
Give a very brief answer. 1.1. What is the ratio of the Aid flow from UN agencies (US$) of Malawi in 1996 to that in 1999?
Keep it short and to the point. 2.6. What is the ratio of the Aid flow from UN agencies (US$) in Nepal in 1996 to that in 1999?
Your response must be concise. 1.14. What is the ratio of the Aid flow from UN agencies (US$) in Low & middle income in 1996 to that in 2000?
Provide a short and direct response. 0.57. What is the ratio of the Aid flow from UN agencies (US$) of Indonesia in 1996 to that in 2000?
Provide a short and direct response. 0.51. What is the ratio of the Aid flow from UN agencies (US$) of Malawi in 1996 to that in 2000?
Your response must be concise. 2.7. What is the ratio of the Aid flow from UN agencies (US$) in Nepal in 1996 to that in 2000?
Offer a terse response. 1.38. What is the ratio of the Aid flow from UN agencies (US$) of Low & middle income in 1997 to that in 1998?
Provide a succinct answer. 1.11. What is the ratio of the Aid flow from UN agencies (US$) of Indonesia in 1997 to that in 1998?
Ensure brevity in your answer.  1.55. What is the ratio of the Aid flow from UN agencies (US$) in Malawi in 1997 to that in 1998?
Provide a succinct answer. 1.31. What is the ratio of the Aid flow from UN agencies (US$) of Nepal in 1997 to that in 1998?
Give a very brief answer. 1.15. What is the ratio of the Aid flow from UN agencies (US$) in Low & middle income in 1997 to that in 1999?
Keep it short and to the point. 1.03. What is the ratio of the Aid flow from UN agencies (US$) of Indonesia in 1997 to that in 1999?
Your answer should be very brief. 0.84. What is the ratio of the Aid flow from UN agencies (US$) in Malawi in 1997 to that in 1999?
Offer a very short reply. 1.65. What is the ratio of the Aid flow from UN agencies (US$) of Nepal in 1997 to that in 1999?
Ensure brevity in your answer.  1.15. What is the ratio of the Aid flow from UN agencies (US$) in Low & middle income in 1997 to that in 2000?
Ensure brevity in your answer.  0.54. What is the ratio of the Aid flow from UN agencies (US$) in Indonesia in 1997 to that in 2000?
Your response must be concise. 0.64. What is the ratio of the Aid flow from UN agencies (US$) in Malawi in 1997 to that in 2000?
Your answer should be very brief. 1.71. What is the ratio of the Aid flow from UN agencies (US$) in Nepal in 1997 to that in 2000?
Keep it short and to the point. 1.39. What is the ratio of the Aid flow from UN agencies (US$) in Low & middle income in 1998 to that in 1999?
Provide a succinct answer. 0.93. What is the ratio of the Aid flow from UN agencies (US$) in Indonesia in 1998 to that in 1999?
Provide a succinct answer. 0.54. What is the ratio of the Aid flow from UN agencies (US$) of Malawi in 1998 to that in 1999?
Your answer should be very brief. 1.26. What is the ratio of the Aid flow from UN agencies (US$) in Nepal in 1998 to that in 1999?
Your answer should be compact. 1. What is the ratio of the Aid flow from UN agencies (US$) in Low & middle income in 1998 to that in 2000?
Give a very brief answer. 0.49. What is the ratio of the Aid flow from UN agencies (US$) of Indonesia in 1998 to that in 2000?
Offer a terse response. 0.41. What is the ratio of the Aid flow from UN agencies (US$) in Malawi in 1998 to that in 2000?
Provide a short and direct response. 1.3. What is the ratio of the Aid flow from UN agencies (US$) in Nepal in 1998 to that in 2000?
Provide a succinct answer. 1.21. What is the ratio of the Aid flow from UN agencies (US$) of Low & middle income in 1999 to that in 2000?
Keep it short and to the point. 0.52. What is the ratio of the Aid flow from UN agencies (US$) in Indonesia in 1999 to that in 2000?
Ensure brevity in your answer.  0.76. What is the ratio of the Aid flow from UN agencies (US$) in Malawi in 1999 to that in 2000?
Offer a very short reply. 1.04. What is the ratio of the Aid flow from UN agencies (US$) of Nepal in 1999 to that in 2000?
Keep it short and to the point. 1.21. What is the difference between the highest and the second highest Aid flow from UN agencies (US$) in Low & middle income?
Make the answer very short. 8.61e+07. What is the difference between the highest and the second highest Aid flow from UN agencies (US$) in Indonesia?
Offer a terse response. 8.20e+05. What is the difference between the highest and the second highest Aid flow from UN agencies (US$) in Malawi?
Keep it short and to the point. 1.47e+07. What is the difference between the highest and the lowest Aid flow from UN agencies (US$) of Low & middle income?
Provide a succinct answer. 7.18e+08. What is the difference between the highest and the lowest Aid flow from UN agencies (US$) in Indonesia?
Offer a terse response. 1.54e+06. What is the difference between the highest and the lowest Aid flow from UN agencies (US$) of Malawi?
Ensure brevity in your answer.  1.82e+07. What is the difference between the highest and the lowest Aid flow from UN agencies (US$) in Nepal?
Make the answer very short. 2.49e+06. 